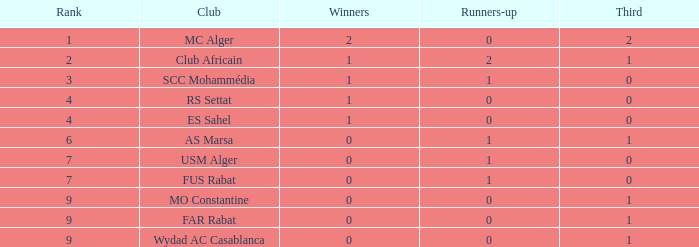Could you help me parse every detail presented in this table? {'header': ['Rank', 'Club', 'Winners', 'Runners-up', 'Third'], 'rows': [['1', 'MC Alger', '2', '0', '2'], ['2', 'Club Africain', '1', '2', '1'], ['3', 'SCC Mohammédia', '1', '1', '0'], ['4', 'RS Settat', '1', '0', '0'], ['4', 'ES Sahel', '1', '0', '0'], ['6', 'AS Marsa', '0', '1', '1'], ['7', 'USM Alger', '0', '1', '0'], ['7', 'FUS Rabat', '0', '1', '0'], ['9', 'MO Constantine', '0', '0', '1'], ['9', 'FAR Rabat', '0', '0', '1'], ['9', 'Wydad AC Casablanca', '0', '0', '1']]} Which Rank has a Third of 2, and Winners smaller than 2? None. 